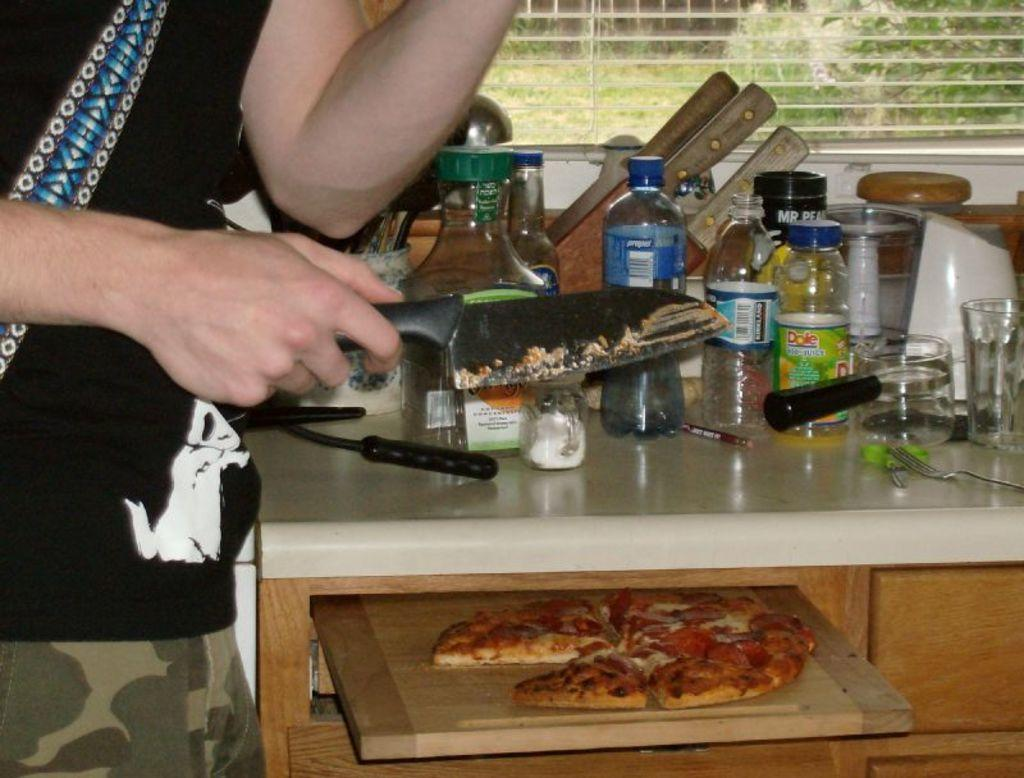Provide a one-sentence caption for the provided image. A person is cutting a pizza on a cutting board by some Dole juice. 